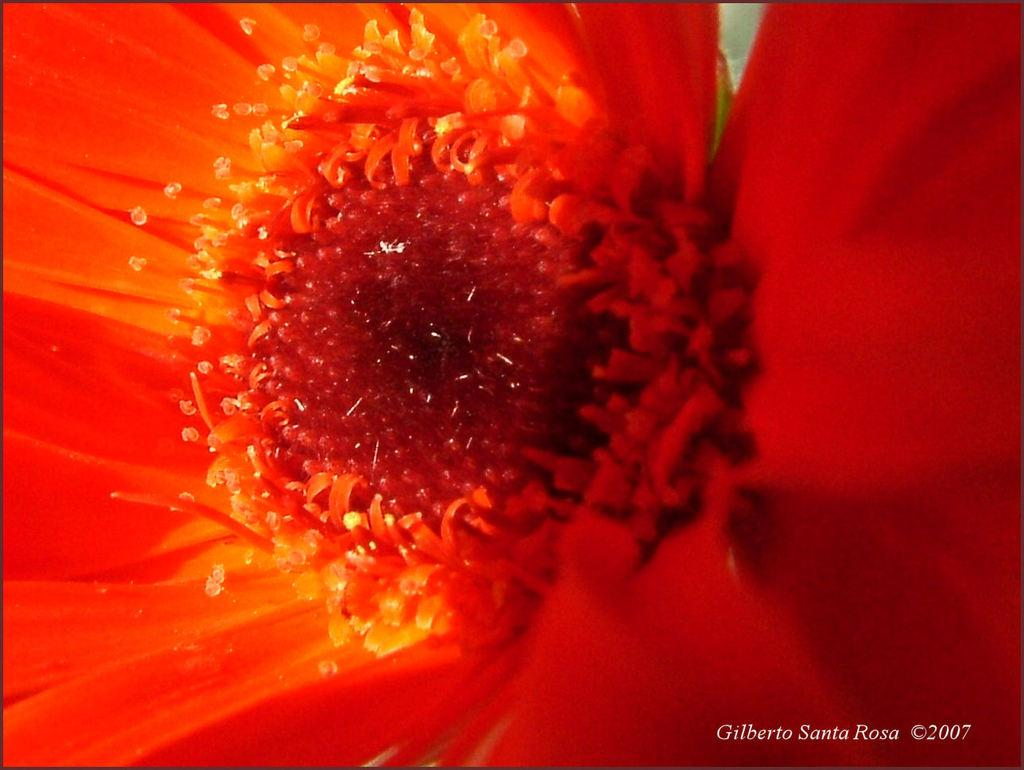What type of plant can be seen in the image? There is a flower in the image. What additional feature is present in the image? There is a watermark in the image. What type of content can be found in the image? Some text is visible in the image. Are there any numerical elements in the image? Yes, numbers are visible in the image. What type of bird is perched on the scarecrow in the image? There is no bird or scarecrow present in the image; it only contains a flower, watermark, text, and numbers. 